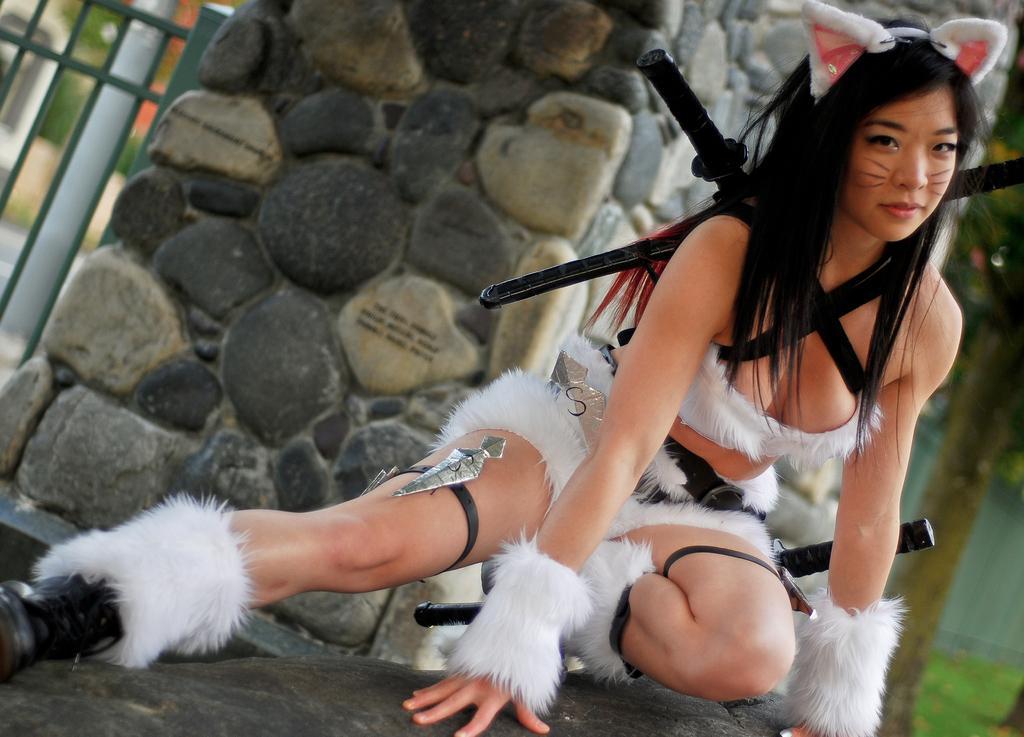In one or two sentences, can you explain what this image depicts? In this picture, we can see a woman in the fancy dress is in squat position and behind the woman there is a stone wall, fence and other things. 